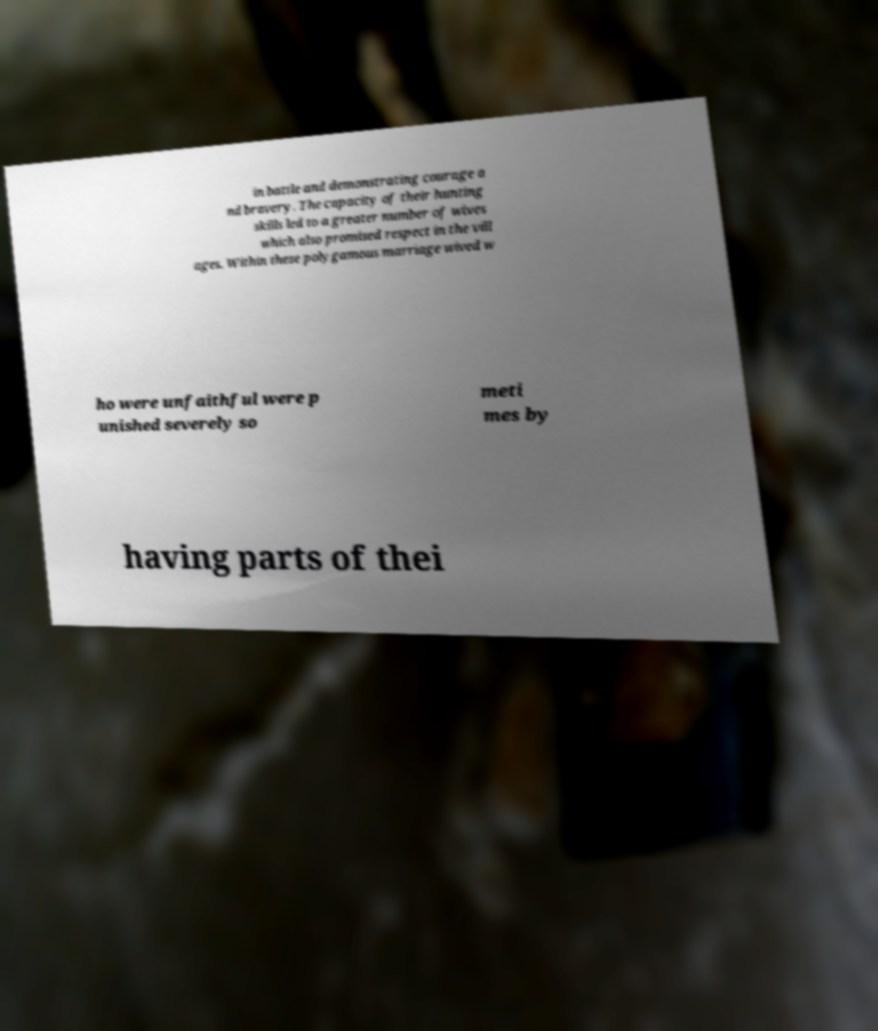I need the written content from this picture converted into text. Can you do that? in battle and demonstrating courage a nd bravery. The capacity of their hunting skills led to a greater number of wives which also promised respect in the vill ages. Within these polygamous marriage wived w ho were unfaithful were p unished severely so meti mes by having parts of thei 